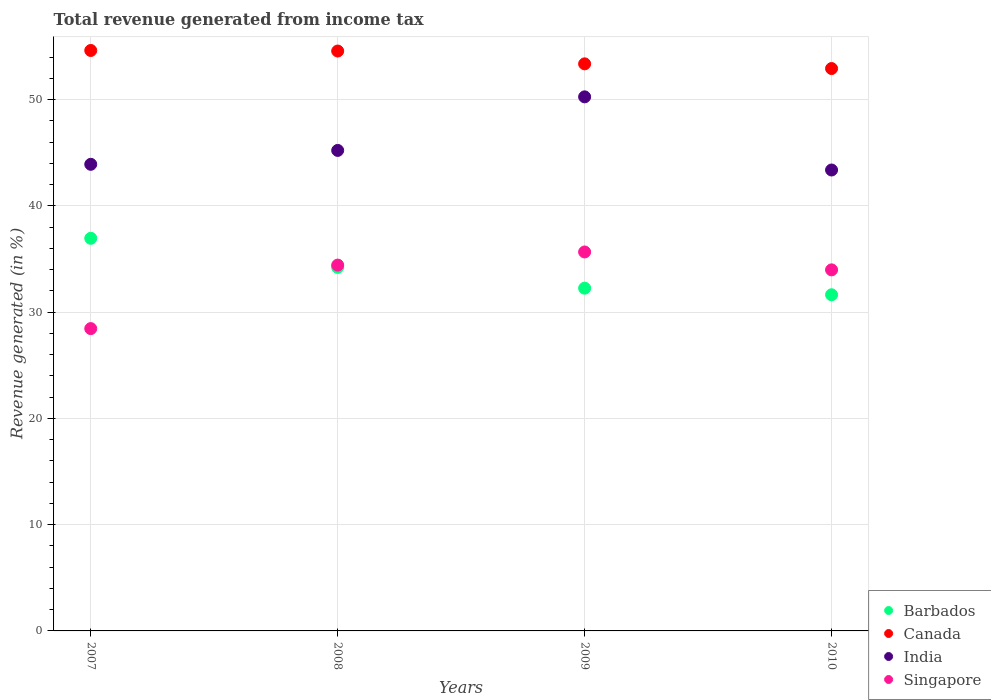Is the number of dotlines equal to the number of legend labels?
Provide a short and direct response. Yes. What is the total revenue generated in Canada in 2010?
Your response must be concise. 52.94. Across all years, what is the maximum total revenue generated in Singapore?
Ensure brevity in your answer.  35.67. Across all years, what is the minimum total revenue generated in Canada?
Your response must be concise. 52.94. In which year was the total revenue generated in Barbados minimum?
Your response must be concise. 2010. What is the total total revenue generated in Barbados in the graph?
Your answer should be very brief. 135.08. What is the difference between the total revenue generated in Canada in 2007 and that in 2010?
Give a very brief answer. 1.7. What is the difference between the total revenue generated in Singapore in 2007 and the total revenue generated in India in 2009?
Provide a short and direct response. -21.81. What is the average total revenue generated in Barbados per year?
Provide a short and direct response. 33.77. In the year 2007, what is the difference between the total revenue generated in India and total revenue generated in Canada?
Offer a terse response. -10.71. What is the ratio of the total revenue generated in India in 2009 to that in 2010?
Provide a succinct answer. 1.16. Is the total revenue generated in Barbados in 2007 less than that in 2009?
Provide a succinct answer. No. Is the difference between the total revenue generated in India in 2007 and 2010 greater than the difference between the total revenue generated in Canada in 2007 and 2010?
Provide a succinct answer. No. What is the difference between the highest and the second highest total revenue generated in India?
Give a very brief answer. 5.04. What is the difference between the highest and the lowest total revenue generated in India?
Provide a short and direct response. 6.89. Does the total revenue generated in India monotonically increase over the years?
Provide a succinct answer. No. Is the total revenue generated in Barbados strictly less than the total revenue generated in India over the years?
Your answer should be compact. Yes. How many dotlines are there?
Your answer should be very brief. 4. How many years are there in the graph?
Ensure brevity in your answer.  4. What is the difference between two consecutive major ticks on the Y-axis?
Your answer should be very brief. 10. Are the values on the major ticks of Y-axis written in scientific E-notation?
Offer a very short reply. No. Does the graph contain any zero values?
Ensure brevity in your answer.  No. How many legend labels are there?
Give a very brief answer. 4. How are the legend labels stacked?
Your response must be concise. Vertical. What is the title of the graph?
Give a very brief answer. Total revenue generated from income tax. Does "Middle income" appear as one of the legend labels in the graph?
Keep it short and to the point. No. What is the label or title of the Y-axis?
Ensure brevity in your answer.  Revenue generated (in %). What is the Revenue generated (in %) of Barbados in 2007?
Your answer should be compact. 36.96. What is the Revenue generated (in %) in Canada in 2007?
Offer a terse response. 54.64. What is the Revenue generated (in %) in India in 2007?
Keep it short and to the point. 43.92. What is the Revenue generated (in %) in Singapore in 2007?
Provide a succinct answer. 28.46. What is the Revenue generated (in %) in Barbados in 2008?
Provide a succinct answer. 34.22. What is the Revenue generated (in %) of Canada in 2008?
Your answer should be compact. 54.58. What is the Revenue generated (in %) in India in 2008?
Your response must be concise. 45.23. What is the Revenue generated (in %) in Singapore in 2008?
Provide a succinct answer. 34.43. What is the Revenue generated (in %) in Barbados in 2009?
Your answer should be compact. 32.26. What is the Revenue generated (in %) of Canada in 2009?
Keep it short and to the point. 53.38. What is the Revenue generated (in %) in India in 2009?
Give a very brief answer. 50.27. What is the Revenue generated (in %) of Singapore in 2009?
Ensure brevity in your answer.  35.67. What is the Revenue generated (in %) in Barbados in 2010?
Give a very brief answer. 31.64. What is the Revenue generated (in %) of Canada in 2010?
Your answer should be compact. 52.94. What is the Revenue generated (in %) in India in 2010?
Keep it short and to the point. 43.38. What is the Revenue generated (in %) in Singapore in 2010?
Make the answer very short. 33.99. Across all years, what is the maximum Revenue generated (in %) in Barbados?
Offer a terse response. 36.96. Across all years, what is the maximum Revenue generated (in %) in Canada?
Your answer should be very brief. 54.64. Across all years, what is the maximum Revenue generated (in %) of India?
Your response must be concise. 50.27. Across all years, what is the maximum Revenue generated (in %) in Singapore?
Offer a terse response. 35.67. Across all years, what is the minimum Revenue generated (in %) of Barbados?
Provide a succinct answer. 31.64. Across all years, what is the minimum Revenue generated (in %) in Canada?
Make the answer very short. 52.94. Across all years, what is the minimum Revenue generated (in %) of India?
Provide a short and direct response. 43.38. Across all years, what is the minimum Revenue generated (in %) in Singapore?
Keep it short and to the point. 28.46. What is the total Revenue generated (in %) of Barbados in the graph?
Keep it short and to the point. 135.08. What is the total Revenue generated (in %) of Canada in the graph?
Ensure brevity in your answer.  215.53. What is the total Revenue generated (in %) in India in the graph?
Your answer should be very brief. 182.81. What is the total Revenue generated (in %) in Singapore in the graph?
Provide a succinct answer. 132.54. What is the difference between the Revenue generated (in %) of Barbados in 2007 and that in 2008?
Your answer should be compact. 2.74. What is the difference between the Revenue generated (in %) in Canada in 2007 and that in 2008?
Your answer should be very brief. 0.05. What is the difference between the Revenue generated (in %) of India in 2007 and that in 2008?
Keep it short and to the point. -1.31. What is the difference between the Revenue generated (in %) in Singapore in 2007 and that in 2008?
Make the answer very short. -5.98. What is the difference between the Revenue generated (in %) of Barbados in 2007 and that in 2009?
Make the answer very short. 4.69. What is the difference between the Revenue generated (in %) of Canada in 2007 and that in 2009?
Your answer should be very brief. 1.26. What is the difference between the Revenue generated (in %) in India in 2007 and that in 2009?
Provide a short and direct response. -6.35. What is the difference between the Revenue generated (in %) in Singapore in 2007 and that in 2009?
Your answer should be compact. -7.21. What is the difference between the Revenue generated (in %) in Barbados in 2007 and that in 2010?
Give a very brief answer. 5.31. What is the difference between the Revenue generated (in %) in Canada in 2007 and that in 2010?
Offer a terse response. 1.7. What is the difference between the Revenue generated (in %) of India in 2007 and that in 2010?
Give a very brief answer. 0.54. What is the difference between the Revenue generated (in %) in Singapore in 2007 and that in 2010?
Offer a very short reply. -5.53. What is the difference between the Revenue generated (in %) of Barbados in 2008 and that in 2009?
Ensure brevity in your answer.  1.96. What is the difference between the Revenue generated (in %) of Canada in 2008 and that in 2009?
Provide a short and direct response. 1.21. What is the difference between the Revenue generated (in %) of India in 2008 and that in 2009?
Your answer should be very brief. -5.04. What is the difference between the Revenue generated (in %) of Singapore in 2008 and that in 2009?
Ensure brevity in your answer.  -1.24. What is the difference between the Revenue generated (in %) of Barbados in 2008 and that in 2010?
Offer a terse response. 2.58. What is the difference between the Revenue generated (in %) in Canada in 2008 and that in 2010?
Offer a terse response. 1.65. What is the difference between the Revenue generated (in %) in India in 2008 and that in 2010?
Your answer should be compact. 1.84. What is the difference between the Revenue generated (in %) in Singapore in 2008 and that in 2010?
Your answer should be very brief. 0.45. What is the difference between the Revenue generated (in %) of Barbados in 2009 and that in 2010?
Give a very brief answer. 0.62. What is the difference between the Revenue generated (in %) of Canada in 2009 and that in 2010?
Your answer should be compact. 0.44. What is the difference between the Revenue generated (in %) in India in 2009 and that in 2010?
Your answer should be very brief. 6.89. What is the difference between the Revenue generated (in %) in Singapore in 2009 and that in 2010?
Your answer should be compact. 1.68. What is the difference between the Revenue generated (in %) of Barbados in 2007 and the Revenue generated (in %) of Canada in 2008?
Ensure brevity in your answer.  -17.63. What is the difference between the Revenue generated (in %) of Barbados in 2007 and the Revenue generated (in %) of India in 2008?
Provide a short and direct response. -8.27. What is the difference between the Revenue generated (in %) of Barbados in 2007 and the Revenue generated (in %) of Singapore in 2008?
Provide a short and direct response. 2.52. What is the difference between the Revenue generated (in %) in Canada in 2007 and the Revenue generated (in %) in India in 2008?
Make the answer very short. 9.41. What is the difference between the Revenue generated (in %) of Canada in 2007 and the Revenue generated (in %) of Singapore in 2008?
Your answer should be compact. 20.2. What is the difference between the Revenue generated (in %) of India in 2007 and the Revenue generated (in %) of Singapore in 2008?
Provide a succinct answer. 9.49. What is the difference between the Revenue generated (in %) of Barbados in 2007 and the Revenue generated (in %) of Canada in 2009?
Ensure brevity in your answer.  -16.42. What is the difference between the Revenue generated (in %) of Barbados in 2007 and the Revenue generated (in %) of India in 2009?
Your response must be concise. -13.31. What is the difference between the Revenue generated (in %) in Barbados in 2007 and the Revenue generated (in %) in Singapore in 2009?
Your response must be concise. 1.29. What is the difference between the Revenue generated (in %) in Canada in 2007 and the Revenue generated (in %) in India in 2009?
Keep it short and to the point. 4.36. What is the difference between the Revenue generated (in %) of Canada in 2007 and the Revenue generated (in %) of Singapore in 2009?
Your response must be concise. 18.97. What is the difference between the Revenue generated (in %) in India in 2007 and the Revenue generated (in %) in Singapore in 2009?
Offer a terse response. 8.25. What is the difference between the Revenue generated (in %) of Barbados in 2007 and the Revenue generated (in %) of Canada in 2010?
Make the answer very short. -15.98. What is the difference between the Revenue generated (in %) in Barbados in 2007 and the Revenue generated (in %) in India in 2010?
Offer a very short reply. -6.43. What is the difference between the Revenue generated (in %) of Barbados in 2007 and the Revenue generated (in %) of Singapore in 2010?
Give a very brief answer. 2.97. What is the difference between the Revenue generated (in %) in Canada in 2007 and the Revenue generated (in %) in India in 2010?
Your answer should be compact. 11.25. What is the difference between the Revenue generated (in %) of Canada in 2007 and the Revenue generated (in %) of Singapore in 2010?
Offer a very short reply. 20.65. What is the difference between the Revenue generated (in %) in India in 2007 and the Revenue generated (in %) in Singapore in 2010?
Your answer should be compact. 9.94. What is the difference between the Revenue generated (in %) of Barbados in 2008 and the Revenue generated (in %) of Canada in 2009?
Provide a short and direct response. -19.16. What is the difference between the Revenue generated (in %) in Barbados in 2008 and the Revenue generated (in %) in India in 2009?
Ensure brevity in your answer.  -16.05. What is the difference between the Revenue generated (in %) in Barbados in 2008 and the Revenue generated (in %) in Singapore in 2009?
Your answer should be compact. -1.45. What is the difference between the Revenue generated (in %) in Canada in 2008 and the Revenue generated (in %) in India in 2009?
Provide a succinct answer. 4.31. What is the difference between the Revenue generated (in %) of Canada in 2008 and the Revenue generated (in %) of Singapore in 2009?
Give a very brief answer. 18.91. What is the difference between the Revenue generated (in %) in India in 2008 and the Revenue generated (in %) in Singapore in 2009?
Ensure brevity in your answer.  9.56. What is the difference between the Revenue generated (in %) in Barbados in 2008 and the Revenue generated (in %) in Canada in 2010?
Your response must be concise. -18.72. What is the difference between the Revenue generated (in %) in Barbados in 2008 and the Revenue generated (in %) in India in 2010?
Your answer should be compact. -9.17. What is the difference between the Revenue generated (in %) in Barbados in 2008 and the Revenue generated (in %) in Singapore in 2010?
Offer a terse response. 0.23. What is the difference between the Revenue generated (in %) in Canada in 2008 and the Revenue generated (in %) in India in 2010?
Provide a succinct answer. 11.2. What is the difference between the Revenue generated (in %) of Canada in 2008 and the Revenue generated (in %) of Singapore in 2010?
Ensure brevity in your answer.  20.6. What is the difference between the Revenue generated (in %) of India in 2008 and the Revenue generated (in %) of Singapore in 2010?
Offer a very short reply. 11.24. What is the difference between the Revenue generated (in %) of Barbados in 2009 and the Revenue generated (in %) of Canada in 2010?
Your response must be concise. -20.67. What is the difference between the Revenue generated (in %) in Barbados in 2009 and the Revenue generated (in %) in India in 2010?
Offer a terse response. -11.12. What is the difference between the Revenue generated (in %) in Barbados in 2009 and the Revenue generated (in %) in Singapore in 2010?
Your answer should be compact. -1.72. What is the difference between the Revenue generated (in %) of Canada in 2009 and the Revenue generated (in %) of India in 2010?
Provide a succinct answer. 9.99. What is the difference between the Revenue generated (in %) in Canada in 2009 and the Revenue generated (in %) in Singapore in 2010?
Your answer should be compact. 19.39. What is the difference between the Revenue generated (in %) in India in 2009 and the Revenue generated (in %) in Singapore in 2010?
Your answer should be very brief. 16.29. What is the average Revenue generated (in %) in Barbados per year?
Offer a very short reply. 33.77. What is the average Revenue generated (in %) in Canada per year?
Provide a succinct answer. 53.88. What is the average Revenue generated (in %) of India per year?
Your answer should be compact. 45.7. What is the average Revenue generated (in %) of Singapore per year?
Keep it short and to the point. 33.14. In the year 2007, what is the difference between the Revenue generated (in %) of Barbados and Revenue generated (in %) of Canada?
Your response must be concise. -17.68. In the year 2007, what is the difference between the Revenue generated (in %) of Barbados and Revenue generated (in %) of India?
Your response must be concise. -6.96. In the year 2007, what is the difference between the Revenue generated (in %) of Barbados and Revenue generated (in %) of Singapore?
Give a very brief answer. 8.5. In the year 2007, what is the difference between the Revenue generated (in %) of Canada and Revenue generated (in %) of India?
Your answer should be compact. 10.71. In the year 2007, what is the difference between the Revenue generated (in %) in Canada and Revenue generated (in %) in Singapore?
Make the answer very short. 26.18. In the year 2007, what is the difference between the Revenue generated (in %) of India and Revenue generated (in %) of Singapore?
Offer a terse response. 15.46. In the year 2008, what is the difference between the Revenue generated (in %) in Barbados and Revenue generated (in %) in Canada?
Keep it short and to the point. -20.36. In the year 2008, what is the difference between the Revenue generated (in %) in Barbados and Revenue generated (in %) in India?
Ensure brevity in your answer.  -11.01. In the year 2008, what is the difference between the Revenue generated (in %) of Barbados and Revenue generated (in %) of Singapore?
Ensure brevity in your answer.  -0.21. In the year 2008, what is the difference between the Revenue generated (in %) of Canada and Revenue generated (in %) of India?
Your response must be concise. 9.36. In the year 2008, what is the difference between the Revenue generated (in %) of Canada and Revenue generated (in %) of Singapore?
Your answer should be very brief. 20.15. In the year 2008, what is the difference between the Revenue generated (in %) of India and Revenue generated (in %) of Singapore?
Offer a terse response. 10.79. In the year 2009, what is the difference between the Revenue generated (in %) of Barbados and Revenue generated (in %) of Canada?
Keep it short and to the point. -21.12. In the year 2009, what is the difference between the Revenue generated (in %) of Barbados and Revenue generated (in %) of India?
Your answer should be compact. -18.01. In the year 2009, what is the difference between the Revenue generated (in %) in Barbados and Revenue generated (in %) in Singapore?
Give a very brief answer. -3.41. In the year 2009, what is the difference between the Revenue generated (in %) of Canada and Revenue generated (in %) of India?
Your answer should be compact. 3.11. In the year 2009, what is the difference between the Revenue generated (in %) of Canada and Revenue generated (in %) of Singapore?
Your answer should be very brief. 17.71. In the year 2009, what is the difference between the Revenue generated (in %) in India and Revenue generated (in %) in Singapore?
Keep it short and to the point. 14.6. In the year 2010, what is the difference between the Revenue generated (in %) in Barbados and Revenue generated (in %) in Canada?
Give a very brief answer. -21.29. In the year 2010, what is the difference between the Revenue generated (in %) in Barbados and Revenue generated (in %) in India?
Keep it short and to the point. -11.74. In the year 2010, what is the difference between the Revenue generated (in %) of Barbados and Revenue generated (in %) of Singapore?
Provide a succinct answer. -2.34. In the year 2010, what is the difference between the Revenue generated (in %) in Canada and Revenue generated (in %) in India?
Your answer should be compact. 9.55. In the year 2010, what is the difference between the Revenue generated (in %) of Canada and Revenue generated (in %) of Singapore?
Make the answer very short. 18.95. In the year 2010, what is the difference between the Revenue generated (in %) in India and Revenue generated (in %) in Singapore?
Provide a succinct answer. 9.4. What is the ratio of the Revenue generated (in %) in Barbados in 2007 to that in 2008?
Your response must be concise. 1.08. What is the ratio of the Revenue generated (in %) of Canada in 2007 to that in 2008?
Give a very brief answer. 1. What is the ratio of the Revenue generated (in %) of India in 2007 to that in 2008?
Make the answer very short. 0.97. What is the ratio of the Revenue generated (in %) of Singapore in 2007 to that in 2008?
Ensure brevity in your answer.  0.83. What is the ratio of the Revenue generated (in %) of Barbados in 2007 to that in 2009?
Provide a succinct answer. 1.15. What is the ratio of the Revenue generated (in %) of Canada in 2007 to that in 2009?
Your answer should be very brief. 1.02. What is the ratio of the Revenue generated (in %) of India in 2007 to that in 2009?
Give a very brief answer. 0.87. What is the ratio of the Revenue generated (in %) in Singapore in 2007 to that in 2009?
Your response must be concise. 0.8. What is the ratio of the Revenue generated (in %) of Barbados in 2007 to that in 2010?
Your answer should be very brief. 1.17. What is the ratio of the Revenue generated (in %) of Canada in 2007 to that in 2010?
Your answer should be very brief. 1.03. What is the ratio of the Revenue generated (in %) of India in 2007 to that in 2010?
Your response must be concise. 1.01. What is the ratio of the Revenue generated (in %) in Singapore in 2007 to that in 2010?
Ensure brevity in your answer.  0.84. What is the ratio of the Revenue generated (in %) of Barbados in 2008 to that in 2009?
Offer a terse response. 1.06. What is the ratio of the Revenue generated (in %) in Canada in 2008 to that in 2009?
Provide a short and direct response. 1.02. What is the ratio of the Revenue generated (in %) in India in 2008 to that in 2009?
Ensure brevity in your answer.  0.9. What is the ratio of the Revenue generated (in %) in Singapore in 2008 to that in 2009?
Offer a very short reply. 0.97. What is the ratio of the Revenue generated (in %) of Barbados in 2008 to that in 2010?
Offer a very short reply. 1.08. What is the ratio of the Revenue generated (in %) in Canada in 2008 to that in 2010?
Keep it short and to the point. 1.03. What is the ratio of the Revenue generated (in %) of India in 2008 to that in 2010?
Ensure brevity in your answer.  1.04. What is the ratio of the Revenue generated (in %) of Singapore in 2008 to that in 2010?
Your response must be concise. 1.01. What is the ratio of the Revenue generated (in %) in Barbados in 2009 to that in 2010?
Your answer should be compact. 1.02. What is the ratio of the Revenue generated (in %) in Canada in 2009 to that in 2010?
Make the answer very short. 1.01. What is the ratio of the Revenue generated (in %) in India in 2009 to that in 2010?
Give a very brief answer. 1.16. What is the ratio of the Revenue generated (in %) of Singapore in 2009 to that in 2010?
Make the answer very short. 1.05. What is the difference between the highest and the second highest Revenue generated (in %) of Barbados?
Ensure brevity in your answer.  2.74. What is the difference between the highest and the second highest Revenue generated (in %) in Canada?
Make the answer very short. 0.05. What is the difference between the highest and the second highest Revenue generated (in %) of India?
Give a very brief answer. 5.04. What is the difference between the highest and the second highest Revenue generated (in %) of Singapore?
Your answer should be very brief. 1.24. What is the difference between the highest and the lowest Revenue generated (in %) in Barbados?
Provide a short and direct response. 5.31. What is the difference between the highest and the lowest Revenue generated (in %) of Canada?
Provide a short and direct response. 1.7. What is the difference between the highest and the lowest Revenue generated (in %) in India?
Make the answer very short. 6.89. What is the difference between the highest and the lowest Revenue generated (in %) of Singapore?
Provide a succinct answer. 7.21. 